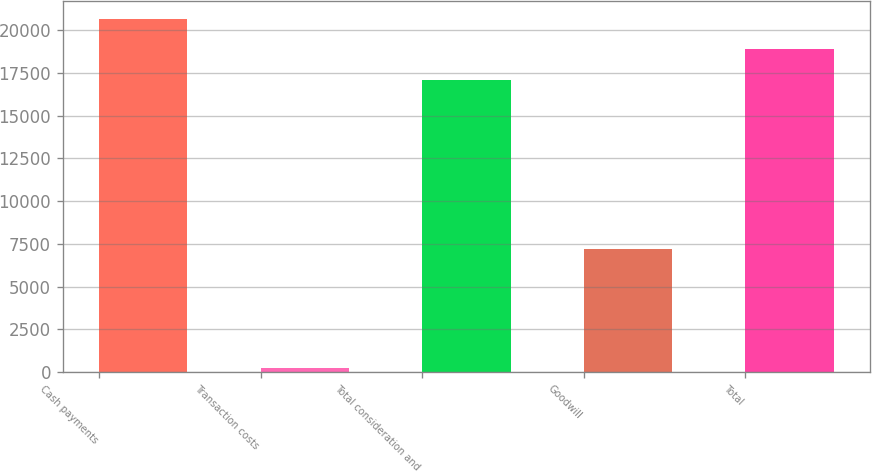Convert chart. <chart><loc_0><loc_0><loc_500><loc_500><bar_chart><fcel>Cash payments<fcel>Transaction costs<fcel>Total consideration and<fcel>Goodwill<fcel>Total<nl><fcel>20665<fcel>216<fcel>17080<fcel>7173<fcel>18872.5<nl></chart> 